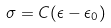<formula> <loc_0><loc_0><loc_500><loc_500>\sigma = C ( \epsilon - \epsilon _ { 0 } )</formula> 